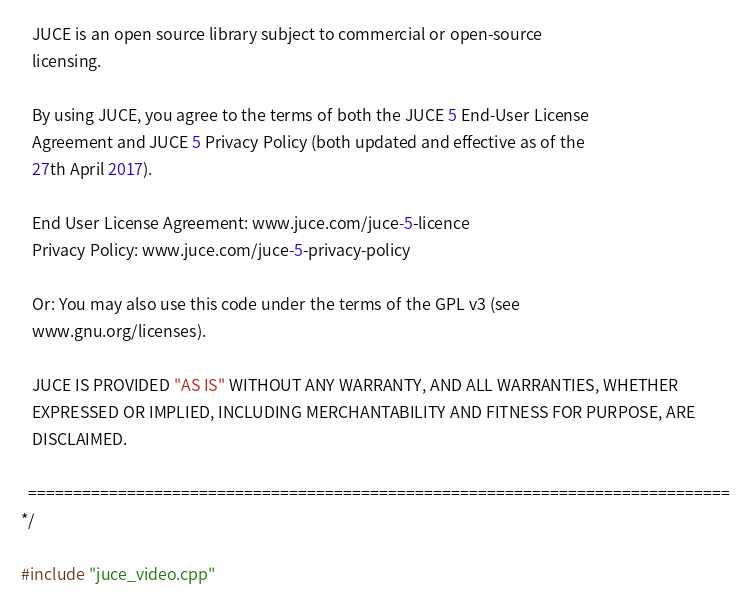Convert code to text. <code><loc_0><loc_0><loc_500><loc_500><_ObjectiveC_>   JUCE is an open source library subject to commercial or open-source
   licensing.

   By using JUCE, you agree to the terms of both the JUCE 5 End-User License
   Agreement and JUCE 5 Privacy Policy (both updated and effective as of the
   27th April 2017).

   End User License Agreement: www.juce.com/juce-5-licence
   Privacy Policy: www.juce.com/juce-5-privacy-policy

   Or: You may also use this code under the terms of the GPL v3 (see
   www.gnu.org/licenses).

   JUCE IS PROVIDED "AS IS" WITHOUT ANY WARRANTY, AND ALL WARRANTIES, WHETHER
   EXPRESSED OR IMPLIED, INCLUDING MERCHANTABILITY AND FITNESS FOR PURPOSE, ARE
   DISCLAIMED.

  ==============================================================================
*/

#include "juce_video.cpp"
</code> 